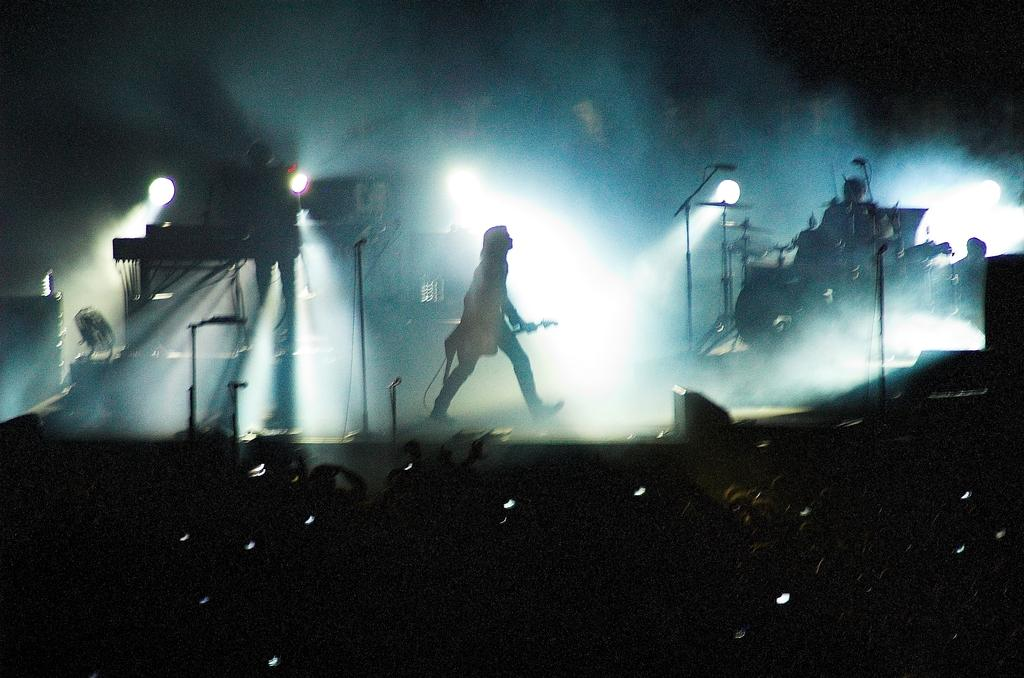What is the main subject of the image? There is a person in the image. What objects are associated with the person in the image? There are microphones, lights, and musical instruments in the image. How many people are present in the image? There is a group of people in the image. What is the color of the background in the image? The background of the image is dark. What type of leg can be seen on the person in the image? There is no specific leg visible in the image; it is a general image of a person with no focus on their legs. 